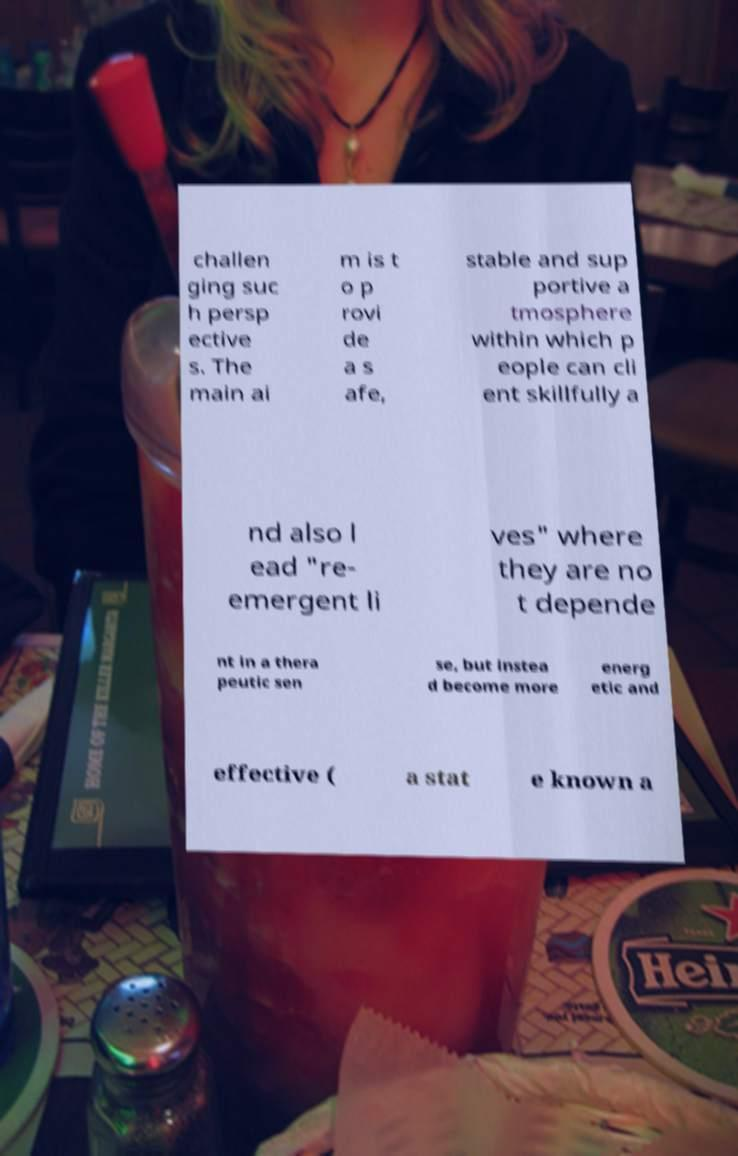For documentation purposes, I need the text within this image transcribed. Could you provide that? challen ging suc h persp ective s. The main ai m is t o p rovi de a s afe, stable and sup portive a tmosphere within which p eople can cli ent skillfully a nd also l ead "re- emergent li ves" where they are no t depende nt in a thera peutic sen se, but instea d become more energ etic and effective ( a stat e known a 